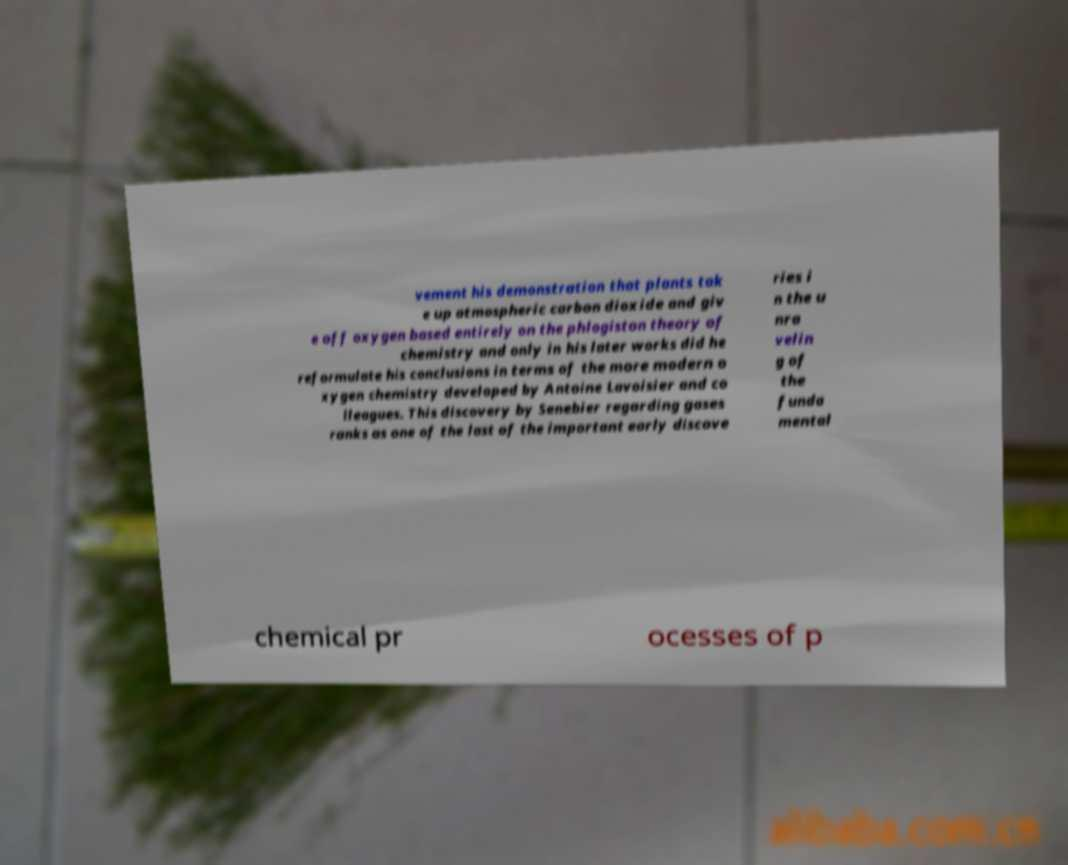For documentation purposes, I need the text within this image transcribed. Could you provide that? vement his demonstration that plants tak e up atmospheric carbon dioxide and giv e off oxygen based entirely on the phlogiston theory of chemistry and only in his later works did he reformulate his conclusions in terms of the more modern o xygen chemistry developed by Antoine Lavoisier and co lleagues. This discovery by Senebier regarding gases ranks as one of the last of the important early discove ries i n the u nra velin g of the funda mental chemical pr ocesses of p 